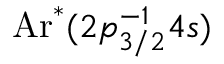<formula> <loc_0><loc_0><loc_500><loc_500>A r ^ { * } ( 2 { p } _ { 3 / 2 } ^ { { - } 1 } 4 s )</formula> 